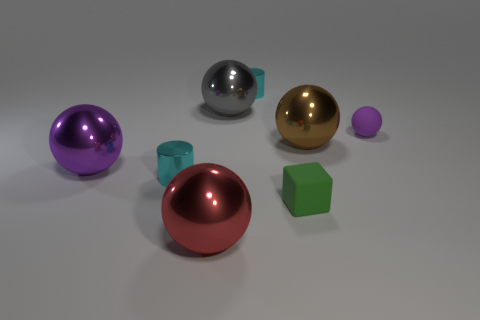Subtract 2 spheres. How many spheres are left? 3 Subtract all red spheres. How many spheres are left? 4 Subtract all purple metallic balls. How many balls are left? 4 Subtract all cyan spheres. Subtract all green cubes. How many spheres are left? 5 Add 2 metallic spheres. How many objects exist? 10 Subtract all balls. How many objects are left? 3 Subtract all red balls. Subtract all brown metal objects. How many objects are left? 6 Add 8 big purple metallic things. How many big purple metallic things are left? 9 Add 2 brown shiny things. How many brown shiny things exist? 3 Subtract 0 cyan blocks. How many objects are left? 8 